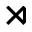Convert formula to latex. <formula><loc_0><loc_0><loc_500><loc_500>\rtimes</formula> 